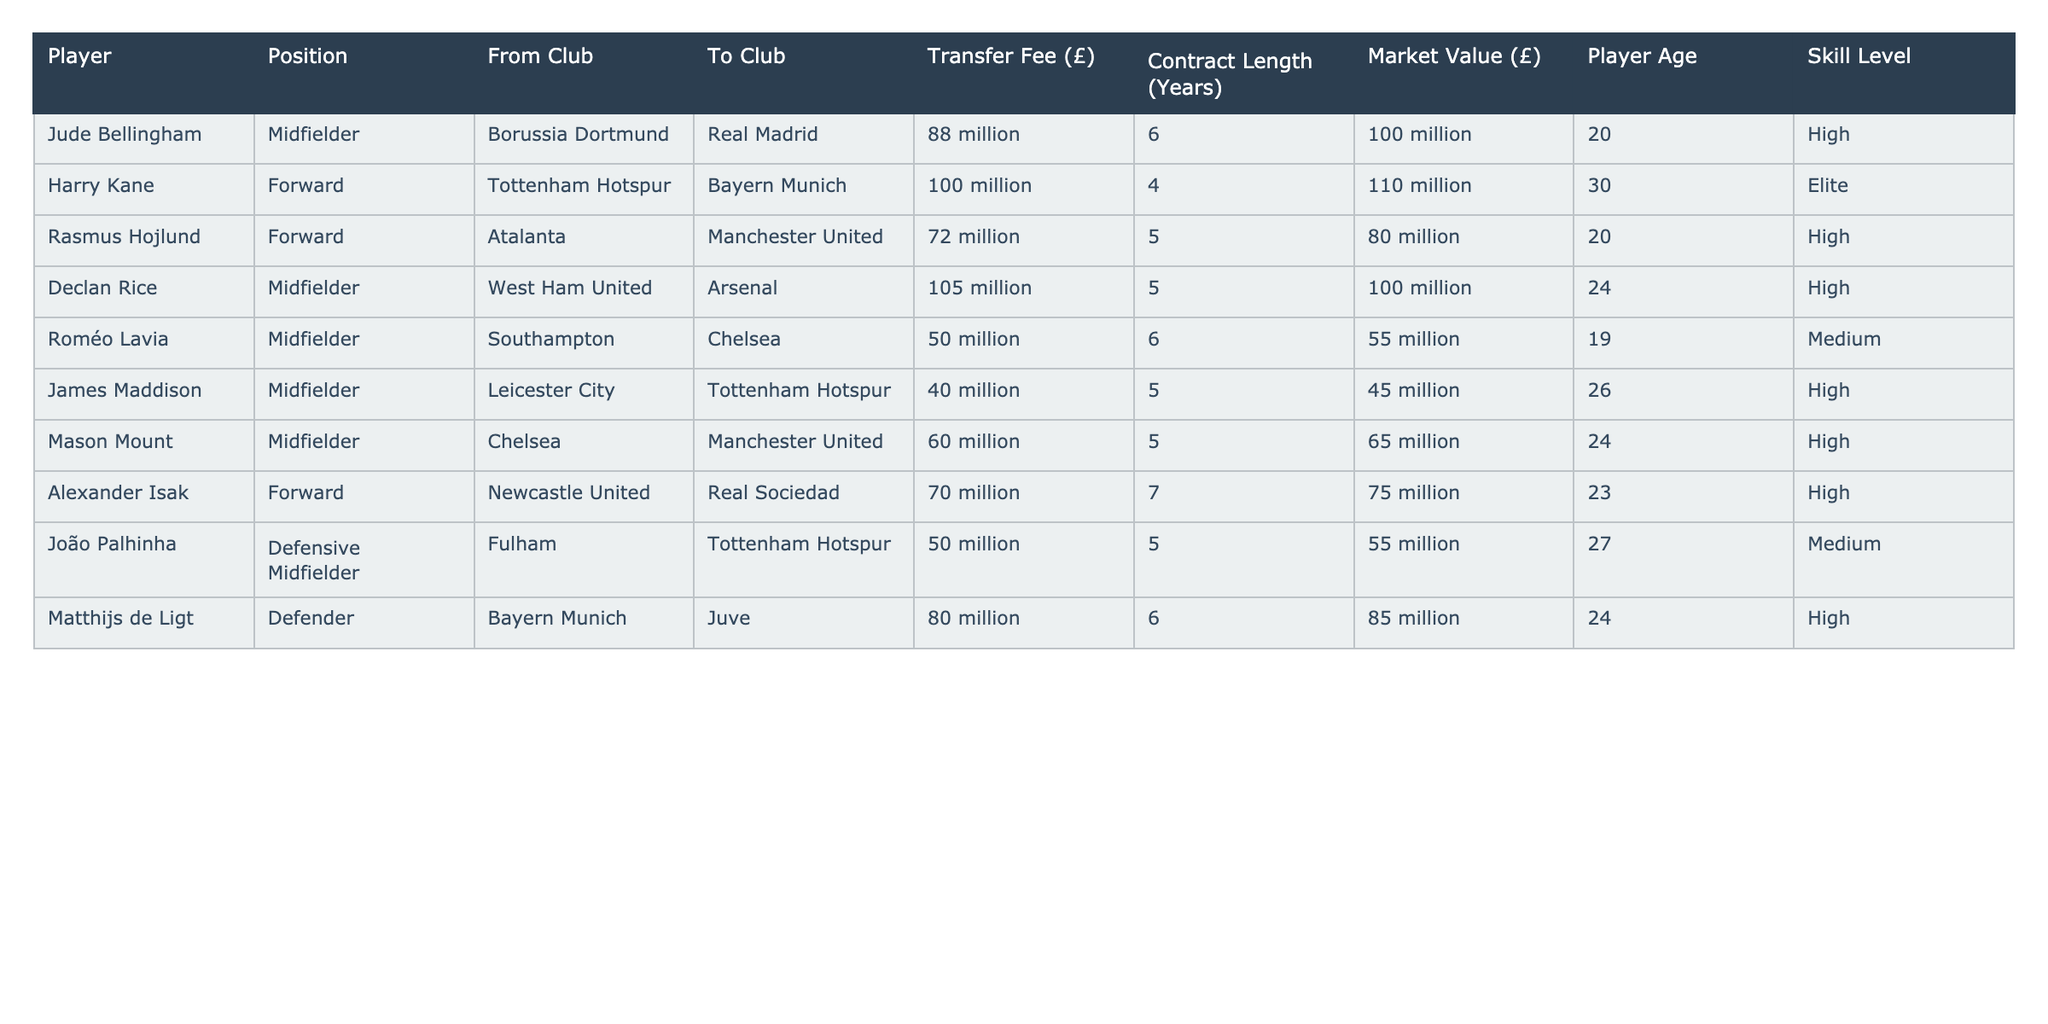What is the transfer fee for Jude Bellingham? According to the table, the transfer fee listed for Jude Bellingham is £88 million.
Answer: £88 million Which player has the highest market value? By inspecting the market values provided in the table, Harry Kane has the highest market value at £110 million.
Answer: £110 million How many years is Declan Rice's contract length? The table shows that Declan Rice's contract length is 5 years.
Answer: 5 years Is Mason Mount's skill level classified as High? The table indicates that Mason Mount has a skill level classified as High.
Answer: Yes What is the average transfer fee of all listed players? To find the average transfer fee, first sum the fees: (88 + 100 + 72 + 105 + 50 + 40 + 60 + 70 + 80) = 615 million. There are 9 players, so the average fee is 615 / 9 approximately £68.33 million.
Answer: £68.33 million How many players transferred to Tottenham Hotspur? Observing the 'To Club' column in the table, three players transferred to Tottenham Hotspur: Rasmus Hojlund, James Maddison, and João Palhinha.
Answer: 3 players Which player is the youngest and what is their age? Examining the 'Player Age' column, Roméo Lavia is identified as the youngest player at 19 years old.
Answer: 19 years What is the total contract length of all players? Adding the contract lengths: (6 + 4 + 5 + 5 + 6 + 5 + 5 + 7 + 6) gives a total of 49 years.
Answer: 49 years Which player has the lowest transfer fee? The table shows that Roméo Lavia has the lowest transfer fee of £50 million.
Answer: £50 million Did any players have a market value under £80 million? By checking the 'Market Value' column, both Roméo Lavia and Alexander Isak have a market value under £80 million.
Answer: Yes 